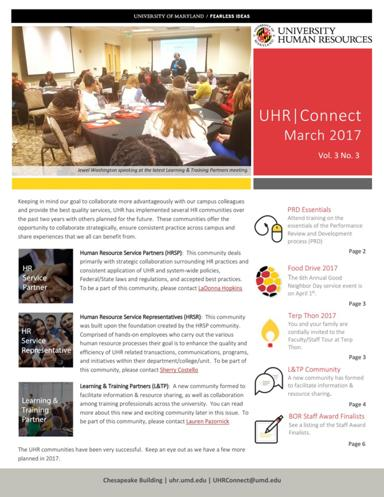What specific departments or initiatives does the newsletter mention? The newsletter mentions several specific departments and initiatives such as HR services, STP Community, and the Learning & Development section, which offers training programs to boost staff capabilities and engagement. 